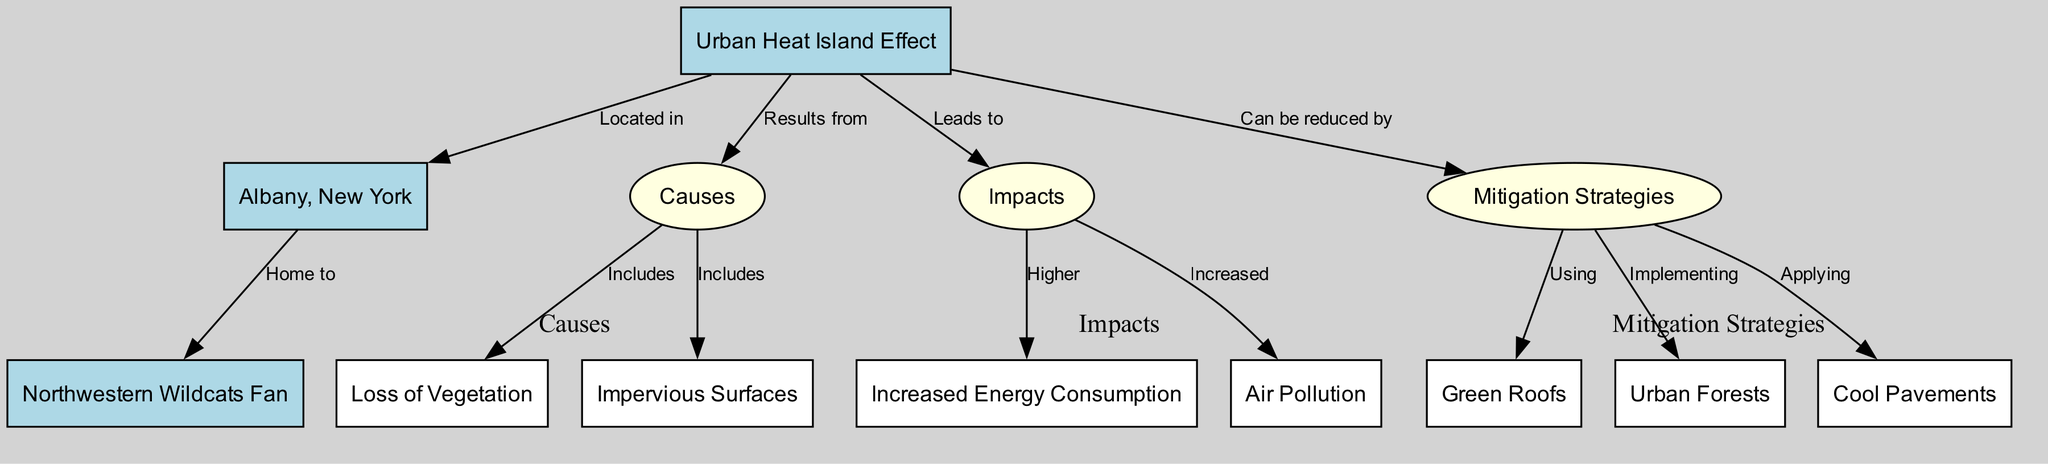what is the main topic of the diagram? The diagram is centered around the "Urban Heat Island Effect," as indicated by the main node labeled "Urban Heat Island Effect." This is the primary subject depicted in the diagram.
Answer: Urban Heat Island Effect what city does the diagram focus on? The diagram specifically mentions "Albany, New York," which is connected to the main topic of the Urban Heat Island Effect as the location being analyzed.
Answer: Albany, New York how many causes of the Urban Heat Island Effect are highlighted in the diagram? The diagram lists two main causes: "Loss of Vegetation" and "Impervious Surfaces," which are connected to the "Causes" node. This represents the total number of causes described.
Answer: 2 what are two impacts of the Urban Heat Island Effect depicted in the diagram? The diagram shows that the impacts of the Urban Heat Island Effect include "Increased Energy Consumption" and "Air Pollution." These are directly linked to the "Impacts" node, indicating they are notable effects of the phenomenon.
Answer: Increased Energy Consumption, Air Pollution which mitigation strategy is related to vegetation? "Urban Forests" is the mitigation strategy that relates specifically to vegetation, as it is connected to the "Mitigation Strategies" node and focuses on planting and maintaining trees in urban areas.
Answer: Urban Forests how does the Urban Heat Island Effect impact energy consumption? The diagram indicates that the Urban Heat Island Effect leads to "Higher Energy Consumption," meaning that as the UHI effect increases, so does the energy needed for cooling and heating. The connection is direct from "Impacts" to "Increased Energy Consumption."
Answer: Higher which mitigation strategy involves modifying pavement? The strategy that involves pavement modification is "Cool Pavements," which is listed under the "Mitigation Strategies" node. This signifies efforts to reduce heat absorption from pavement surfaces in urban areas.
Answer: Cool Pavements what is a primary cause of the Urban Heat Island Effect? A primary cause of the Urban Heat Island Effect as depicted in the diagram is "Loss of Vegetation," which affects the natural cooling mechanisms of urban areas, leading to increased temperatures.
Answer: Loss of Vegetation 